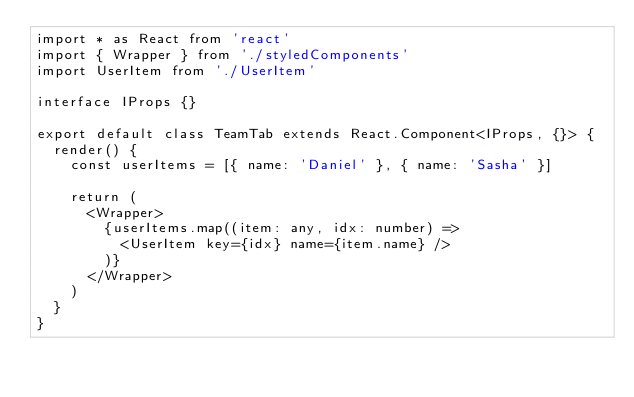Convert code to text. <code><loc_0><loc_0><loc_500><loc_500><_TypeScript_>import * as React from 'react'
import { Wrapper } from './styledComponents'
import UserItem from './UserItem'

interface IProps {}

export default class TeamTab extends React.Component<IProps, {}> {
  render() {
    const userItems = [{ name: 'Daniel' }, { name: 'Sasha' }]

    return (
      <Wrapper>
        {userItems.map((item: any, idx: number) =>
          <UserItem key={idx} name={item.name} />
        )}
      </Wrapper>
    )
  }
}
</code> 